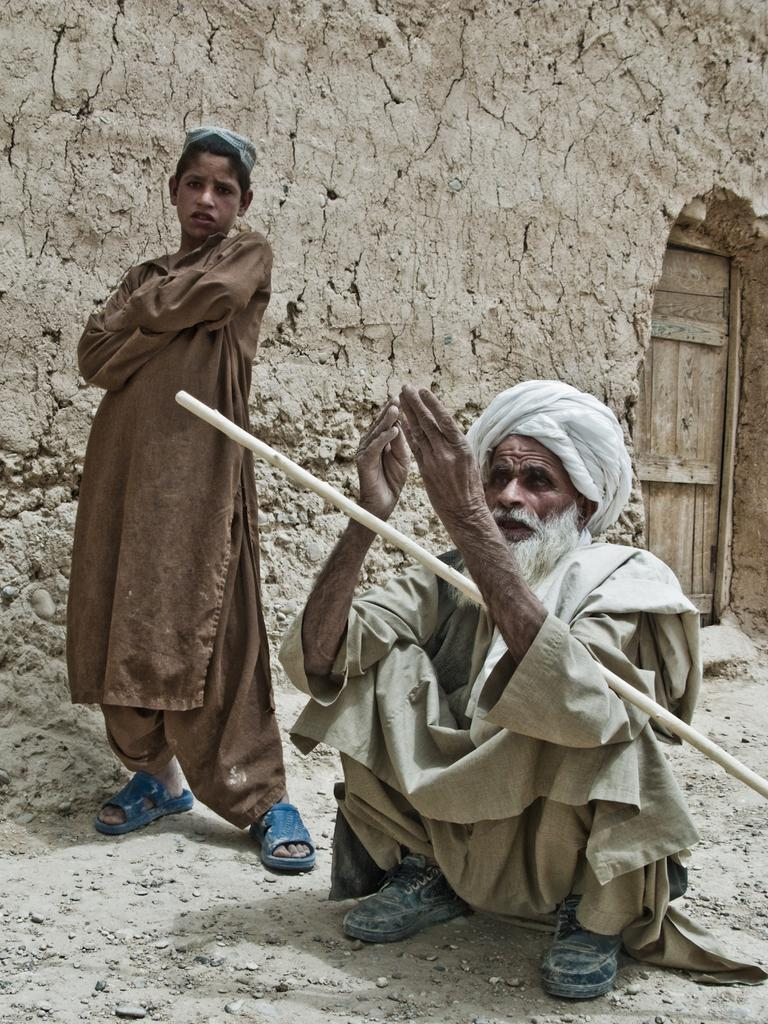How many people are in the image? There are two people in the image, one standing on the left side and one sitting on the right side. What is the position of the wooden door in the image? The wooden door is not mentioned as being in a specific position in the image. Can you describe the actions or postures of the people in the image? One person is standing, and the other is sitting. What type of jam is being spread on the letters in the image? There are no letters or jam present in the image. 